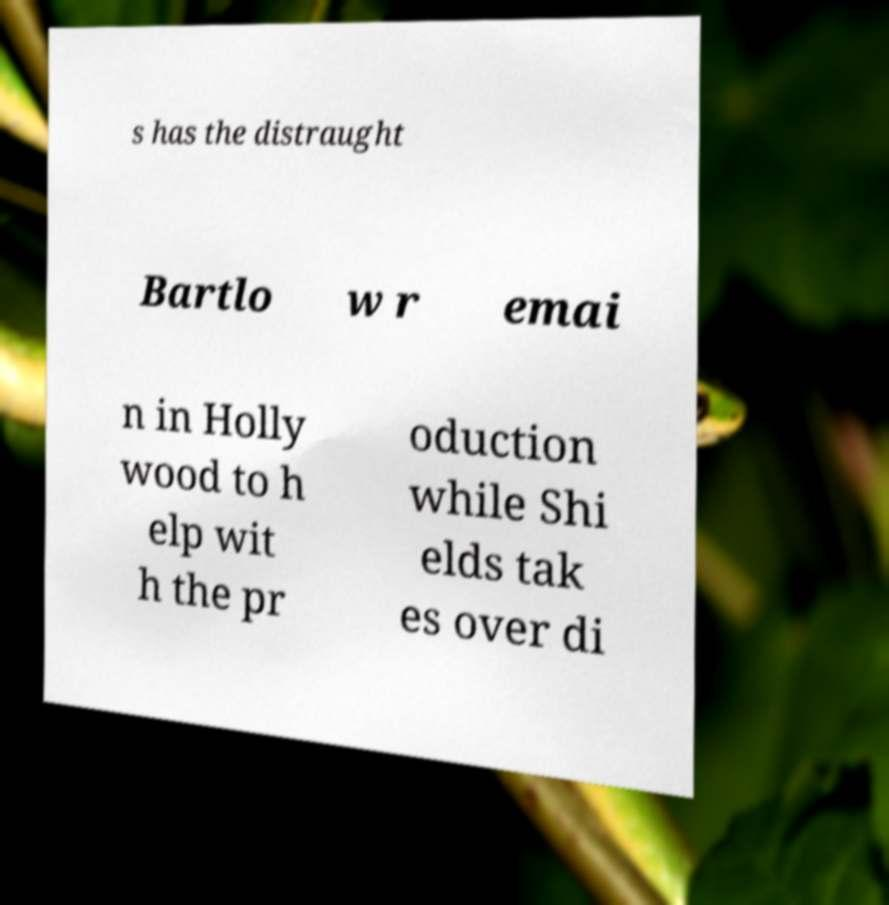What messages or text are displayed in this image? I need them in a readable, typed format. s has the distraught Bartlo w r emai n in Holly wood to h elp wit h the pr oduction while Shi elds tak es over di 